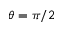Convert formula to latex. <formula><loc_0><loc_0><loc_500><loc_500>\theta = \pi / 2</formula> 